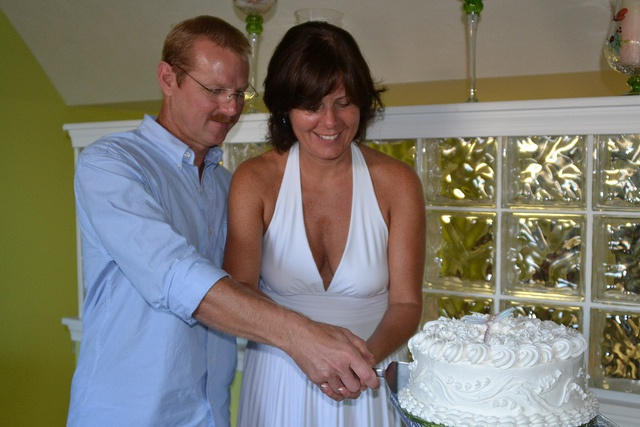Describe the objects in this image and their specific colors. I can see people in gray, darkgray, and brown tones, people in gray, brown, black, darkgray, and maroon tones, cake in gray, lightgray, and darkgray tones, and knife in gray, darkgray, and black tones in this image. 